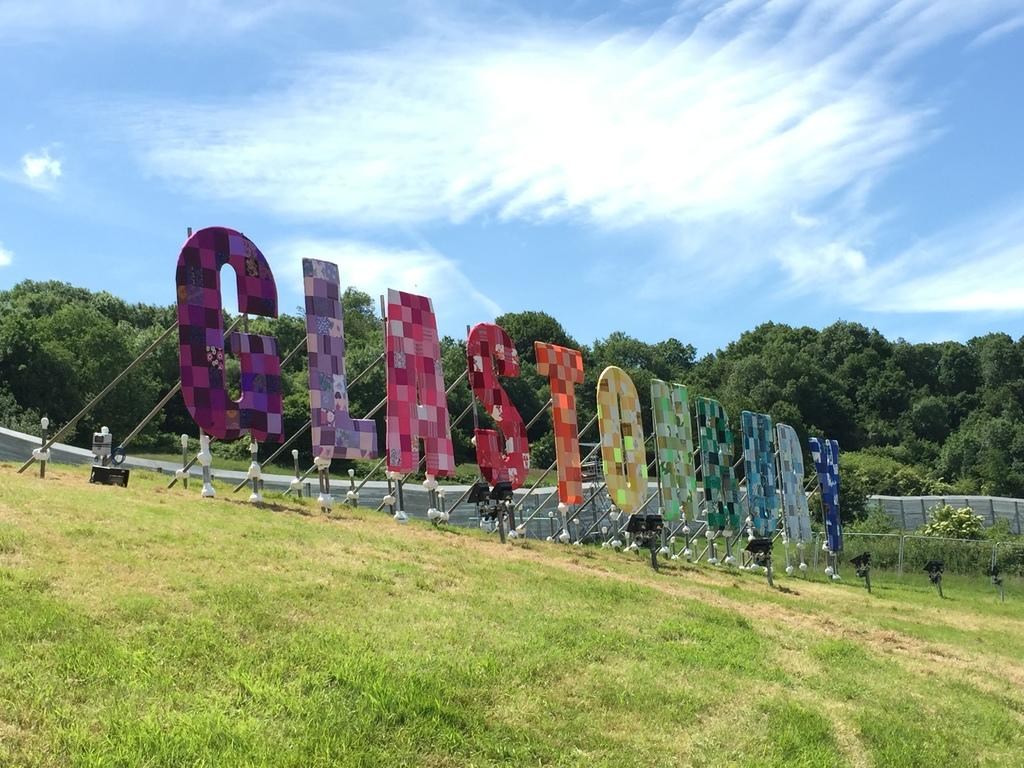What is in the foreground of the image? There is grass in the foreground of the image. What can be seen made of boards in the image? There are boards forming a name with letters in the image. What can be used for illumination in the image? There are lights visible in the image. What type of structure can be seen in the image? There is a compound wall-like structure in the image. What type of vegetation is present in the image? There are trees in the image. What is visible in the background of the image? The sky is visible in the image. What type of orange tree can be seen on the hill in the image? There is no orange tree or hill present in the image. What type of juice is being served in the image? There is no juice present in the image. 